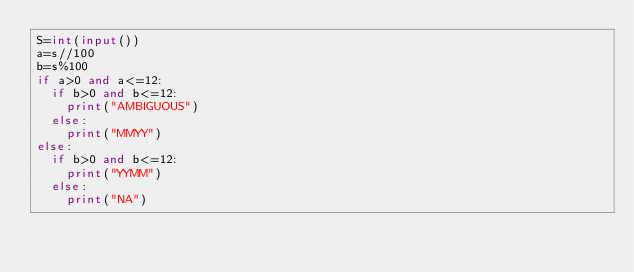Convert code to text. <code><loc_0><loc_0><loc_500><loc_500><_Python_>S=int(input())
a=s//100
b=s%100
if a>0 and a<=12:
  if b>0 and b<=12:
    print("AMBIGUOUS")
  else:
    print("MMYY")
else:
  if b>0 and b<=12:
    print("YYMM")
  else:
    print("NA")</code> 